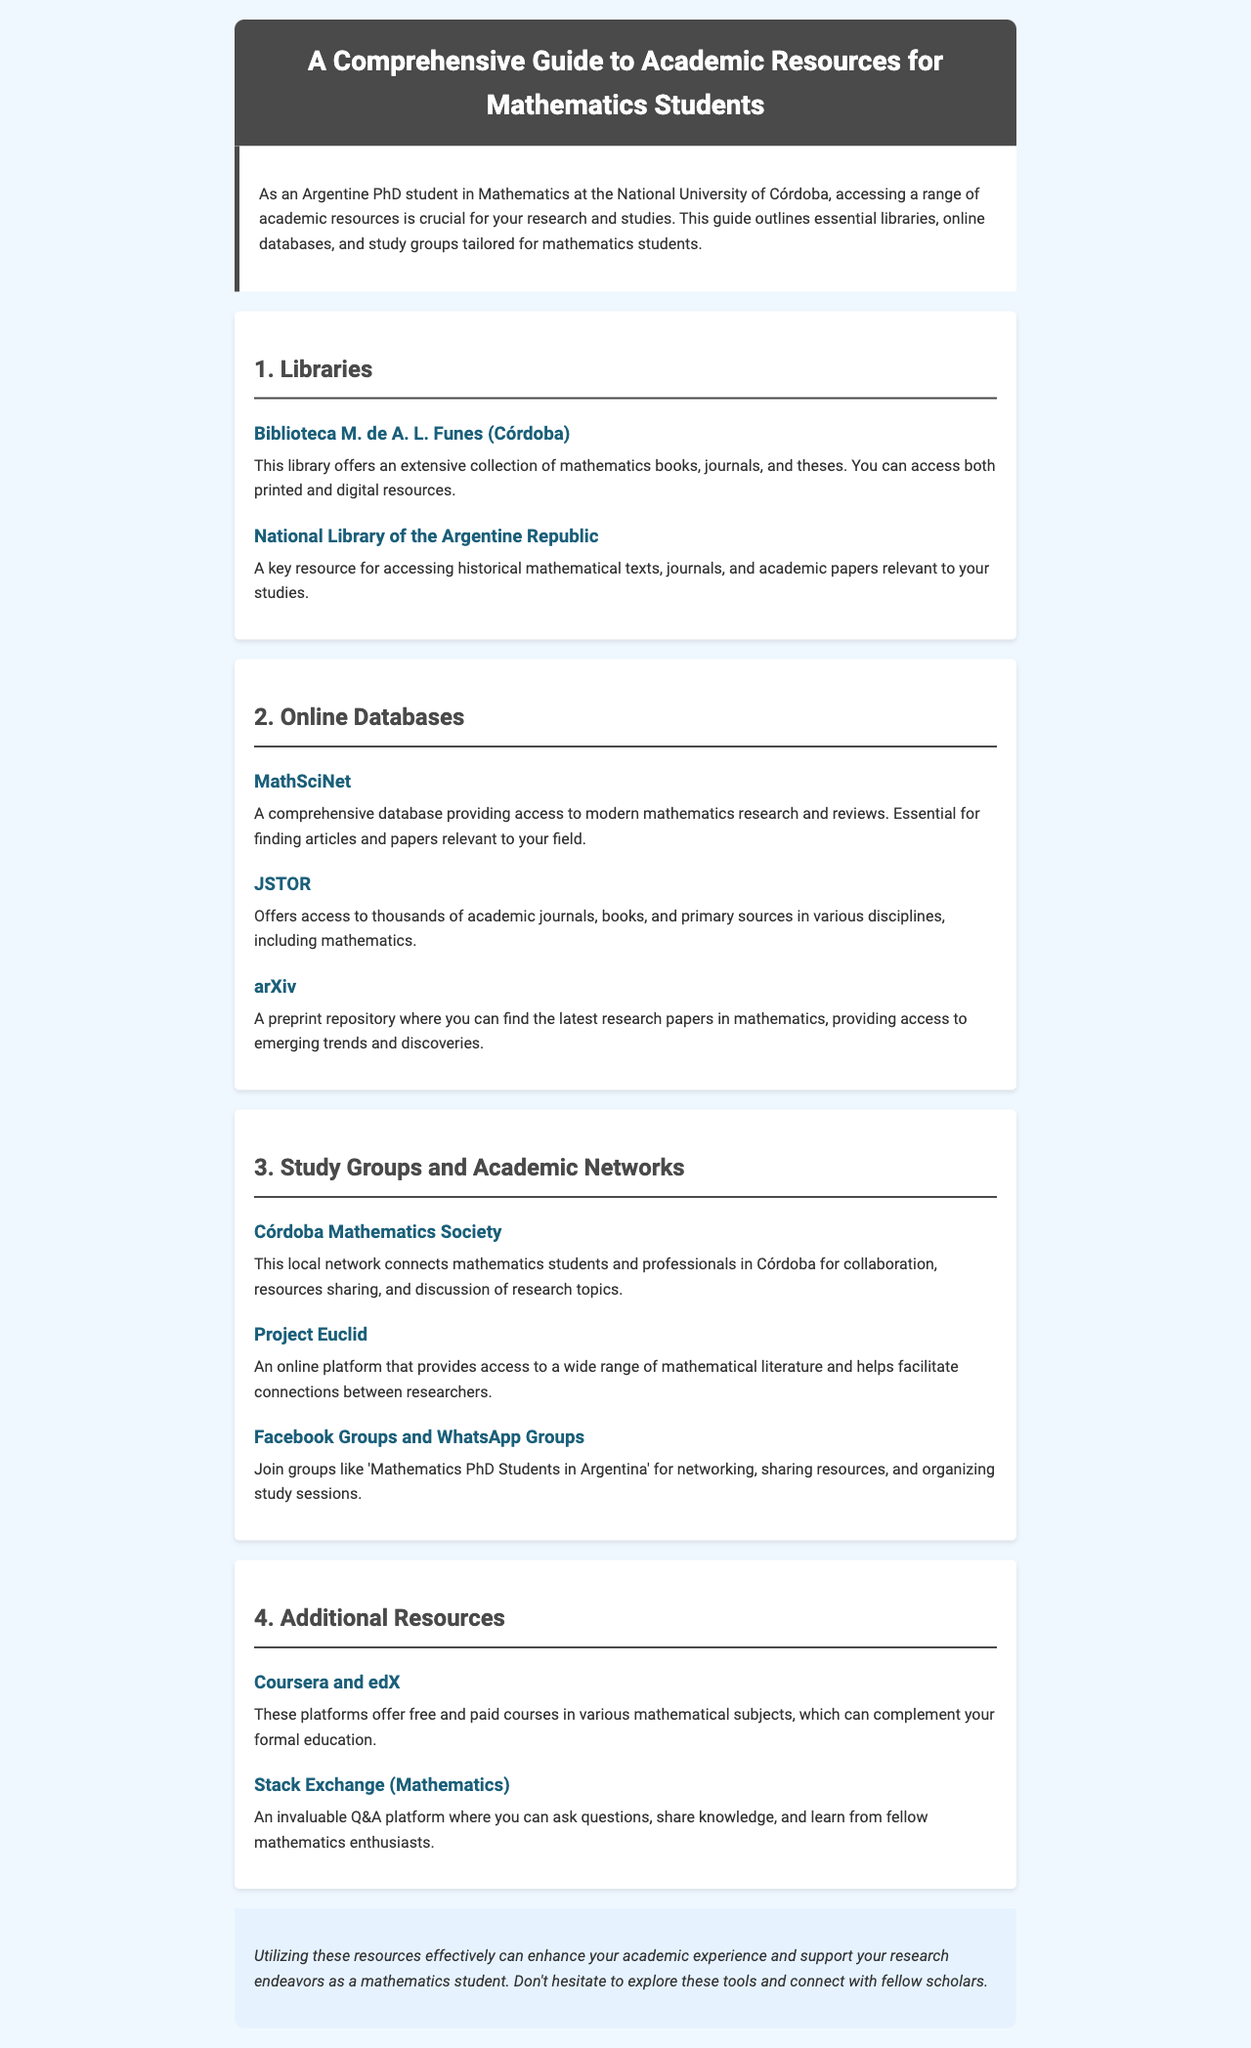what is the title of the newsletter? The title of the newsletter is presented in the header section of the document.
Answer: A Comprehensive Guide to Academic Resources for Mathematics Students which library offers a collection of mathematics books, journals, and theses in Córdoba? The document specifically names a library in Córdoba that provides extensive resources for mathematics.
Answer: Biblioteca M. de A. L. Funes what online database is essential for finding articles and papers relevant to modern mathematics research? The document lists an important online database for mathematics research and reviews.
Answer: MathSciNet what local network connects mathematics students and professionals in Córdoba? The document highlights a specific society that serves as a network for mathematics students and professionals.
Answer: Córdoba Mathematics Society which platforms offer free and paid courses in various mathematical subjects? The document mentions two online platforms that provide educational courses in mathematics.
Answer: Coursera and edX how many main sections are there in the newsletter excluding the introduction and conclusion? By counting the sections within the document, we can determine how many main resource categories are covered.
Answer: Four which social media groups are recommended for networking among mathematics PhD students? The document suggests specific types of social media groups for mathematics PhD students to connect.
Answer: Facebook Groups and WhatsApp Groups what type of resource is arXiv? This refers to the nature of the platform mentioned in the document regarding research papers.
Answer: A preprint repository which Brazilian institution is referenced in the document for accessing historical mathematical texts? The document provides the name of a significant library relevant to mathematics research in Argentina.
Answer: National Library of the Argentine Republic 